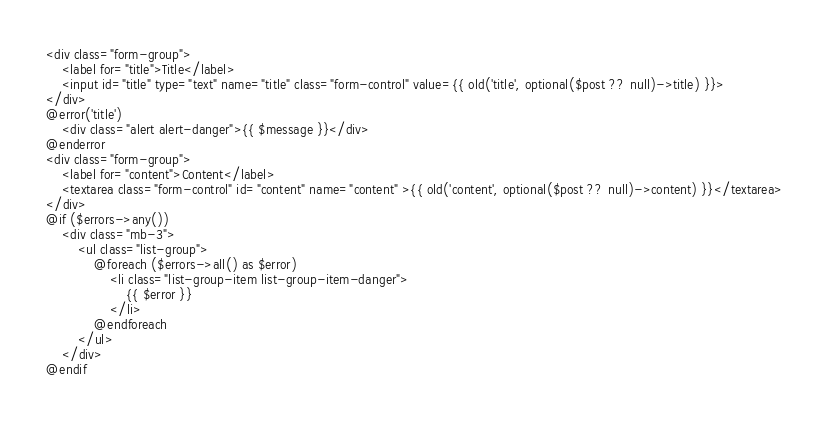Convert code to text. <code><loc_0><loc_0><loc_500><loc_500><_PHP_><div class="form-group">
    <label for="title">Title</label>
    <input id="title" type="text" name="title" class="form-control" value={{ old('title', optional($post ?? null)->title) }}>
</div>
@error('title')
    <div class="alert alert-danger">{{ $message }}</div>
@enderror
<div class="form-group">
    <label for="content">Content</label>
    <textarea class="form-control" id="content" name="content" >{{ old('content', optional($post ?? null)->content) }}</textarea>
</div>
@if ($errors->any())
    <div class="mb-3">
        <ul class="list-group">
            @foreach ($errors->all() as $error)
                <li class="list-group-item list-group-item-danger">
                    {{ $error }}
                </li>
            @endforeach
        </ul>
    </div>
@endif</code> 